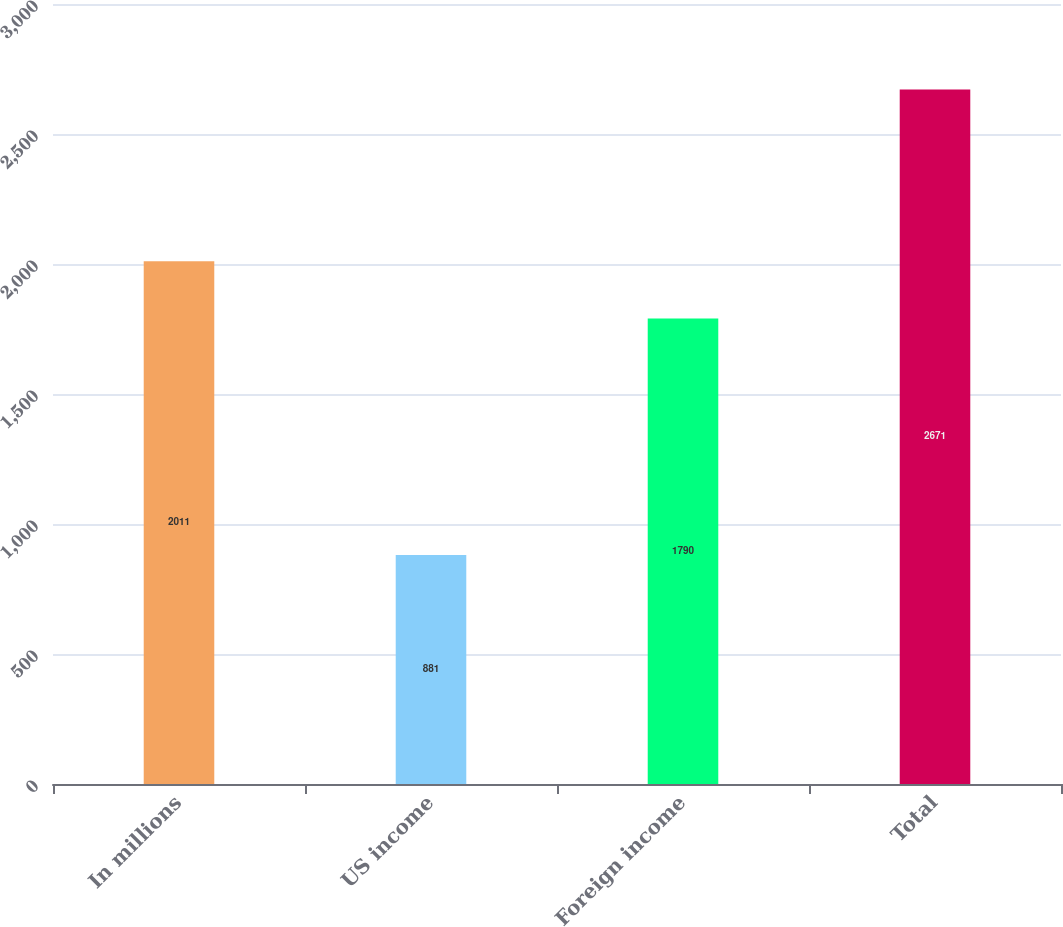Convert chart. <chart><loc_0><loc_0><loc_500><loc_500><bar_chart><fcel>In millions<fcel>US income<fcel>Foreign income<fcel>Total<nl><fcel>2011<fcel>881<fcel>1790<fcel>2671<nl></chart> 